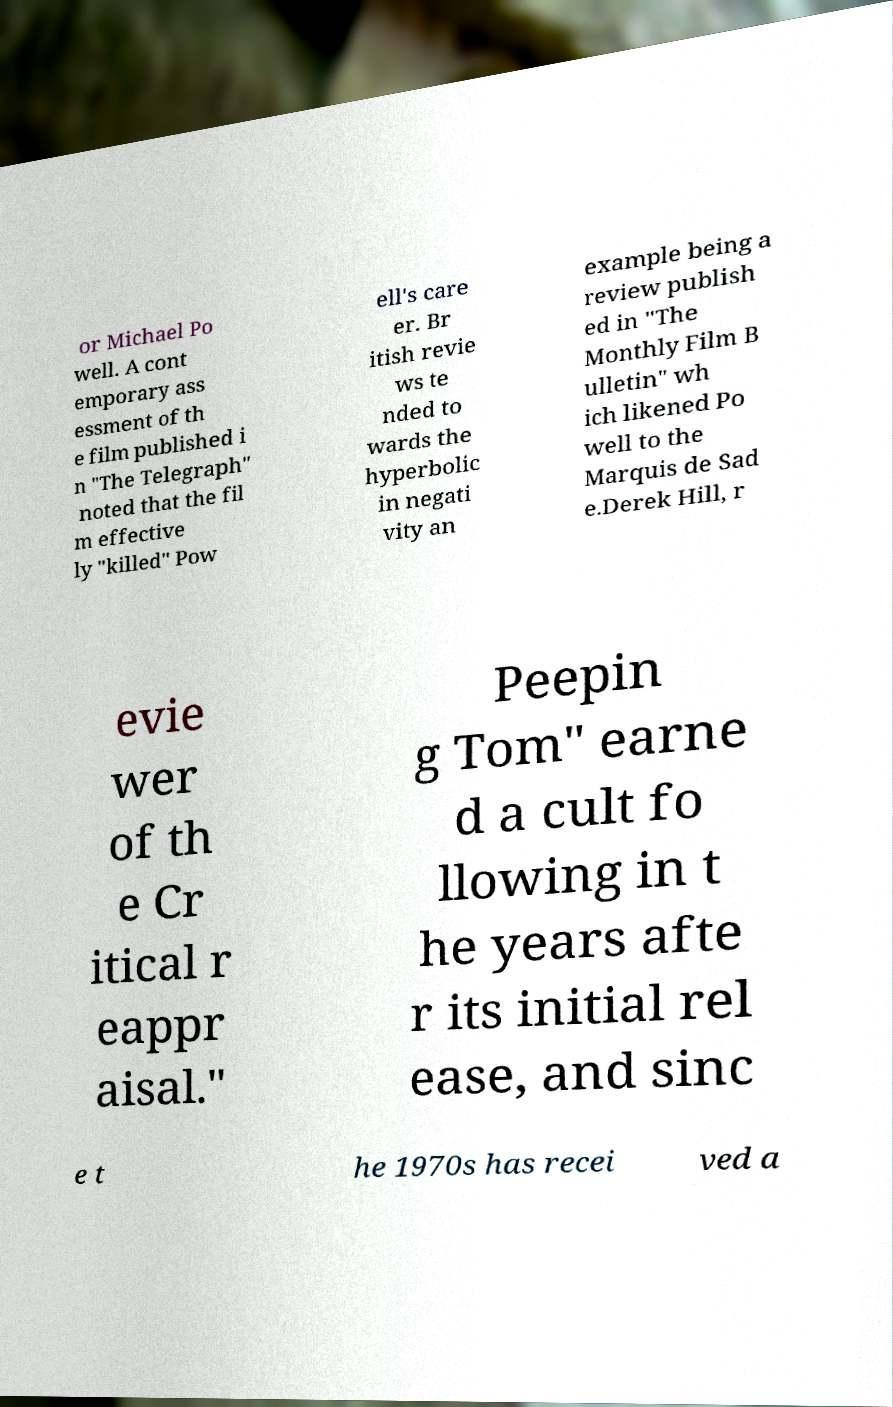For documentation purposes, I need the text within this image transcribed. Could you provide that? or Michael Po well. A cont emporary ass essment of th e film published i n "The Telegraph" noted that the fil m effective ly "killed" Pow ell's care er. Br itish revie ws te nded to wards the hyperbolic in negati vity an example being a review publish ed in "The Monthly Film B ulletin" wh ich likened Po well to the Marquis de Sad e.Derek Hill, r evie wer of th e Cr itical r eappr aisal." Peepin g Tom" earne d a cult fo llowing in t he years afte r its initial rel ease, and sinc e t he 1970s has recei ved a 